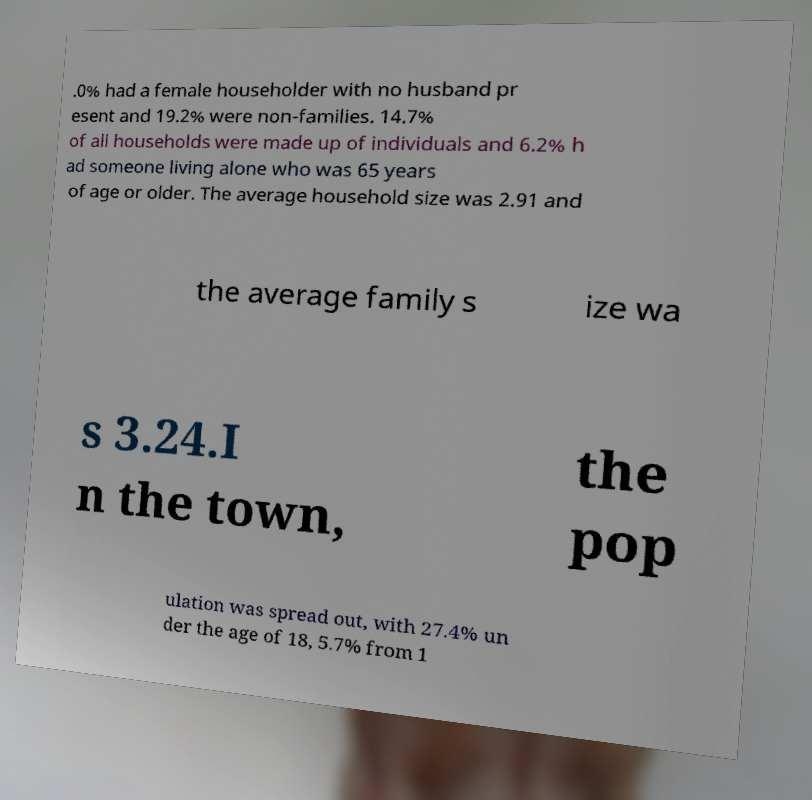Could you extract and type out the text from this image? .0% had a female householder with no husband pr esent and 19.2% were non-families. 14.7% of all households were made up of individuals and 6.2% h ad someone living alone who was 65 years of age or older. The average household size was 2.91 and the average family s ize wa s 3.24.I n the town, the pop ulation was spread out, with 27.4% un der the age of 18, 5.7% from 1 